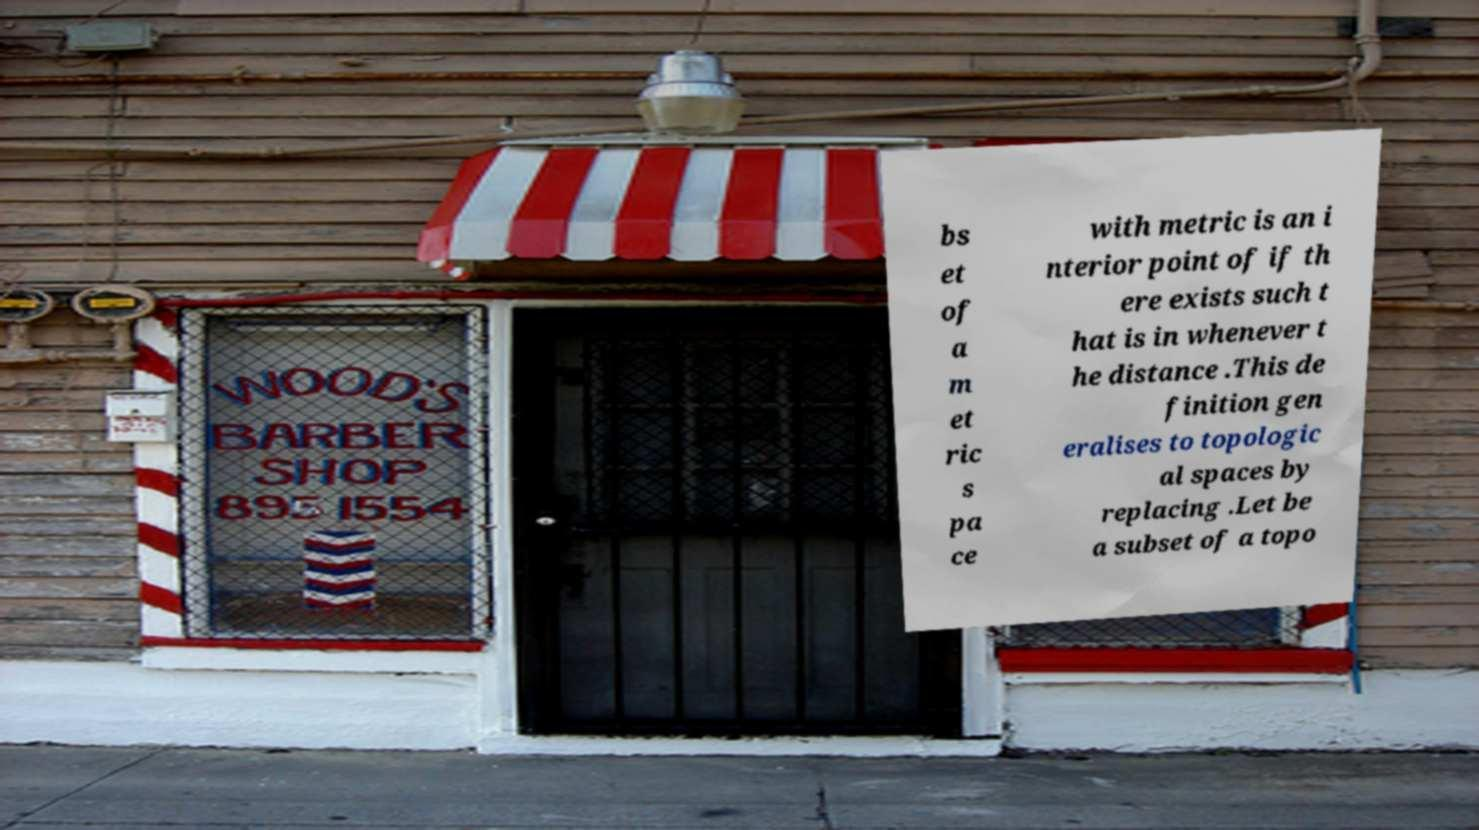For documentation purposes, I need the text within this image transcribed. Could you provide that? bs et of a m et ric s pa ce with metric is an i nterior point of if th ere exists such t hat is in whenever t he distance .This de finition gen eralises to topologic al spaces by replacing .Let be a subset of a topo 